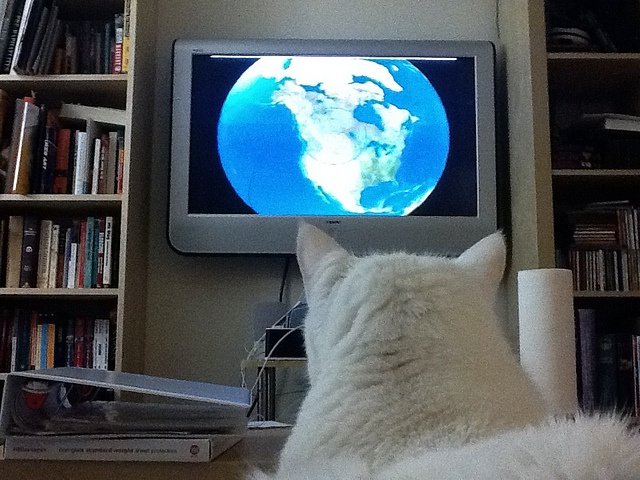Describe the objects in this image and their specific colors. I can see tv in darkgray, gray, lightblue, black, and white tones, book in darkgray, black, and gray tones, cat in darkgray and gray tones, book in black, gray, and darkgray tones, and book in darkgray, black, and gray tones in this image. 